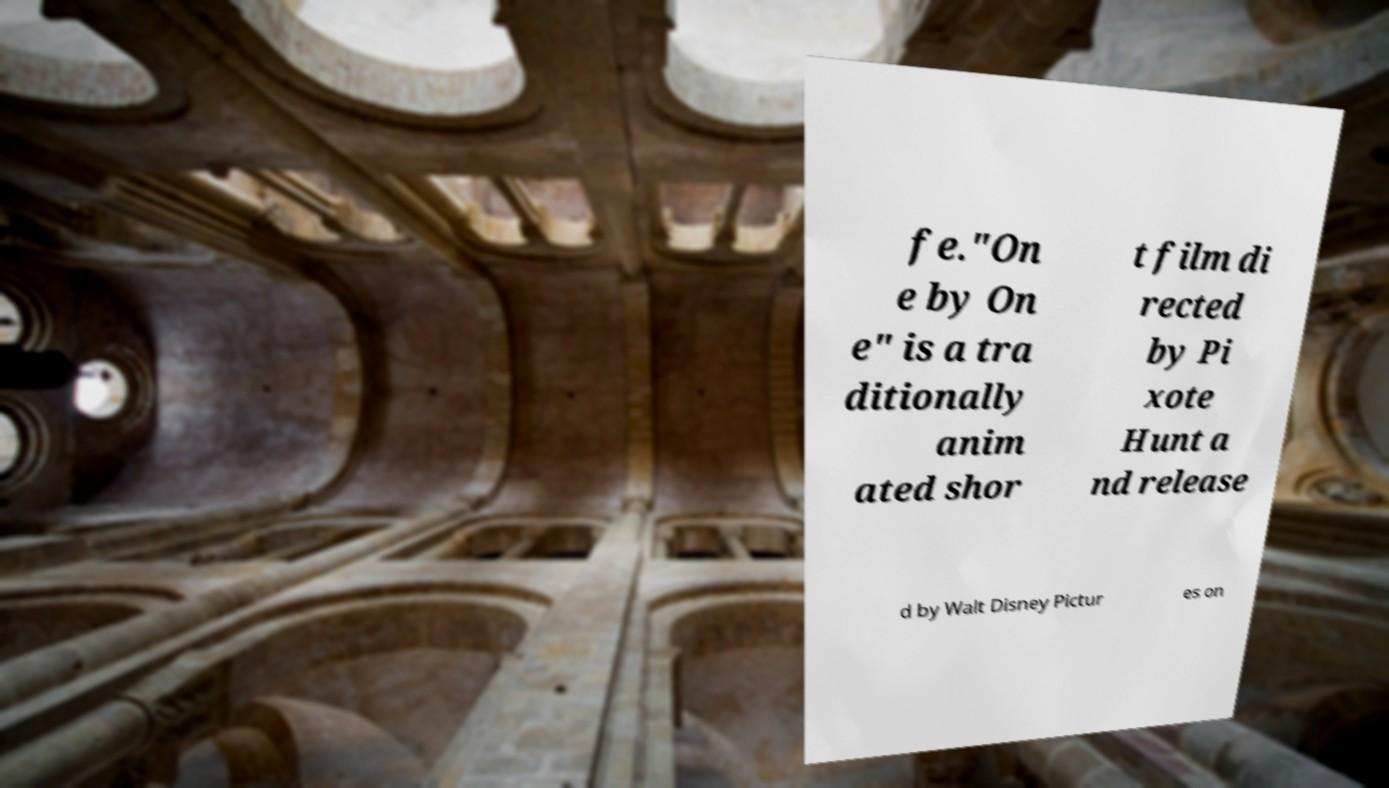Could you extract and type out the text from this image? fe."On e by On e" is a tra ditionally anim ated shor t film di rected by Pi xote Hunt a nd release d by Walt Disney Pictur es on 